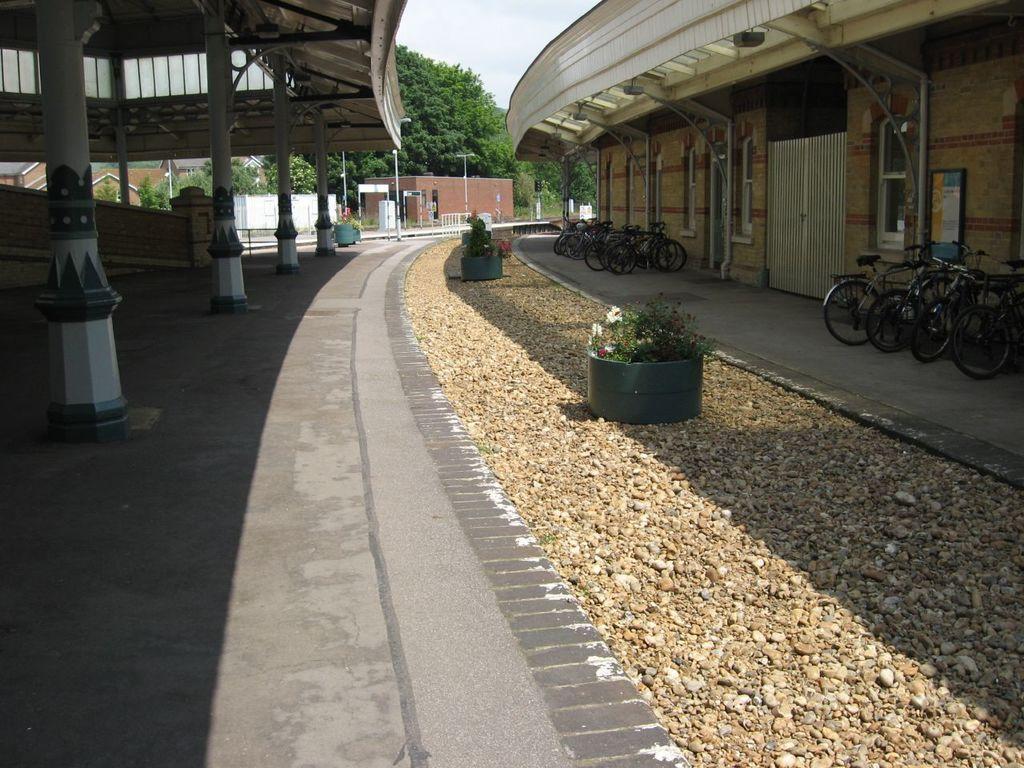In one or two sentences, can you explain what this image depicts? In this picture we can see few buildings, plants, stones and bicycles, in the background we can find few trees, poles and few metal rods. 